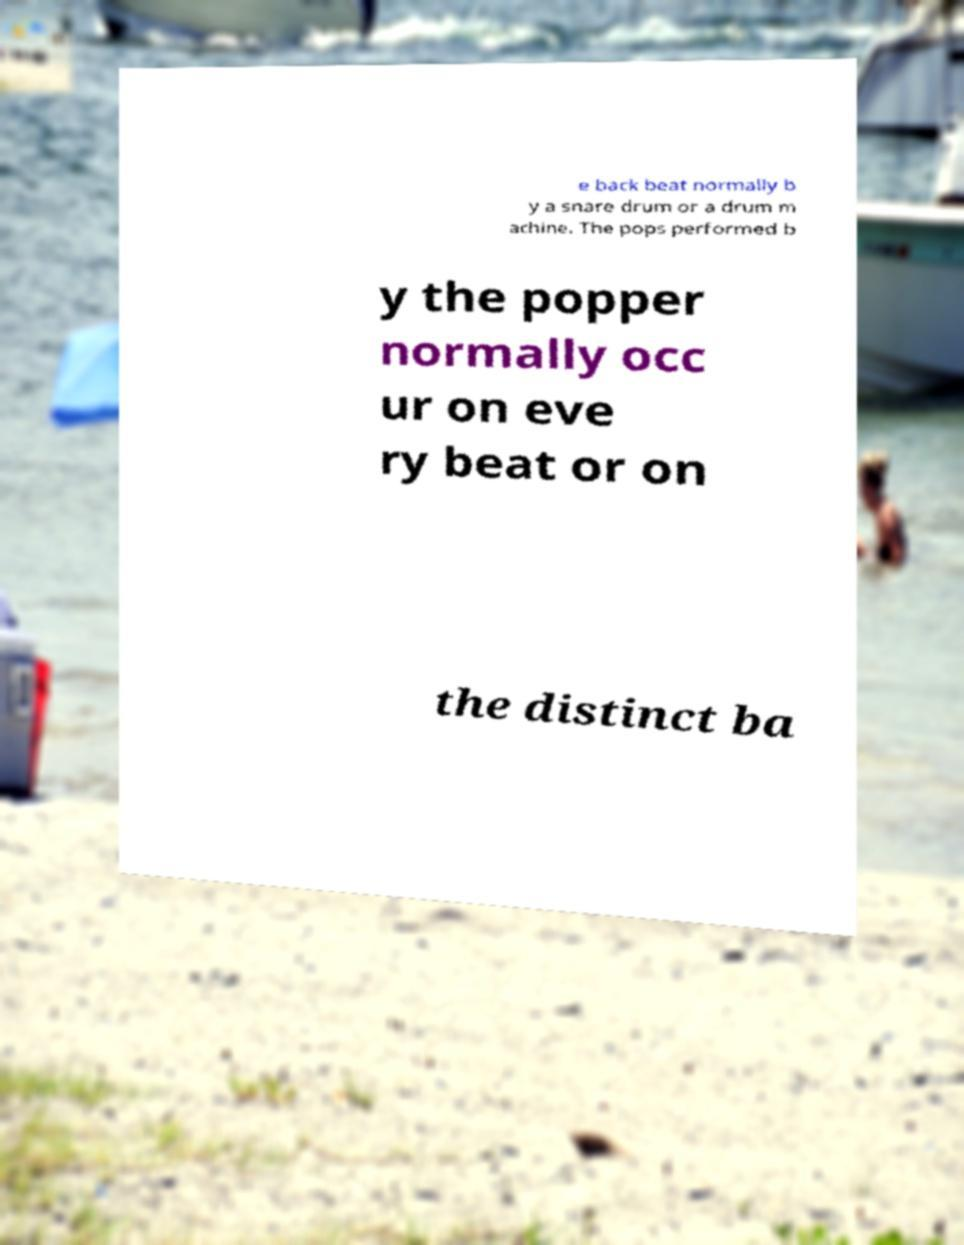I need the written content from this picture converted into text. Can you do that? e back beat normally b y a snare drum or a drum m achine. The pops performed b y the popper normally occ ur on eve ry beat or on the distinct ba 